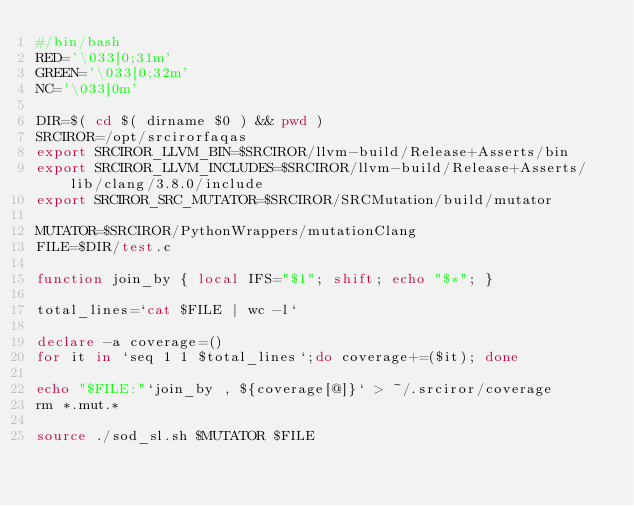<code> <loc_0><loc_0><loc_500><loc_500><_Bash_>#/bin/bash
RED='\033[0;31m'
GREEN='\033[0;32m'
NC='\033[0m'

DIR=$( cd $( dirname $0 ) && pwd )
SRCIROR=/opt/srcirorfaqas
export SRCIROR_LLVM_BIN=$SRCIROR/llvm-build/Release+Asserts/bin
export SRCIROR_LLVM_INCLUDES=$SRCIROR/llvm-build/Release+Asserts/lib/clang/3.8.0/include
export SRCIROR_SRC_MUTATOR=$SRCIROR/SRCMutation/build/mutator

MUTATOR=$SRCIROR/PythonWrappers/mutationClang
FILE=$DIR/test.c

function join_by { local IFS="$1"; shift; echo "$*"; }

total_lines=`cat $FILE | wc -l`

declare -a coverage=()
for it in `seq 1 1 $total_lines`;do coverage+=($it); done

echo "$FILE:"`join_by , ${coverage[@]}` > ~/.srciror/coverage
rm *.mut.*  

source ./sod_sl.sh $MUTATOR $FILE
</code> 